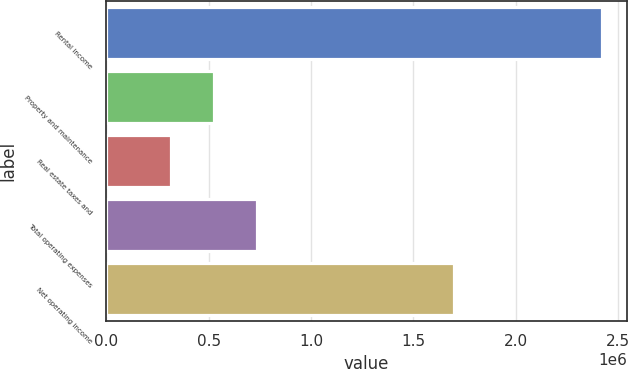Convert chart to OTSL. <chart><loc_0><loc_0><loc_500><loc_500><bar_chart><fcel>Rental income<fcel>Property and maintenance<fcel>Real estate taxes and<fcel>Total operating expenses<fcel>Net operating income<nl><fcel>2.42223e+06<fcel>527872<fcel>317387<fcel>738356<fcel>1.69802e+06<nl></chart> 